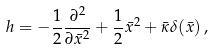<formula> <loc_0><loc_0><loc_500><loc_500>h = - \frac { 1 } { 2 } \frac { \partial ^ { 2 } } { \partial \bar { x } ^ { 2 } } + \frac { 1 } { 2 } \bar { x } ^ { 2 } + \bar { \kappa } \delta ( \bar { x } ) \, ,</formula> 